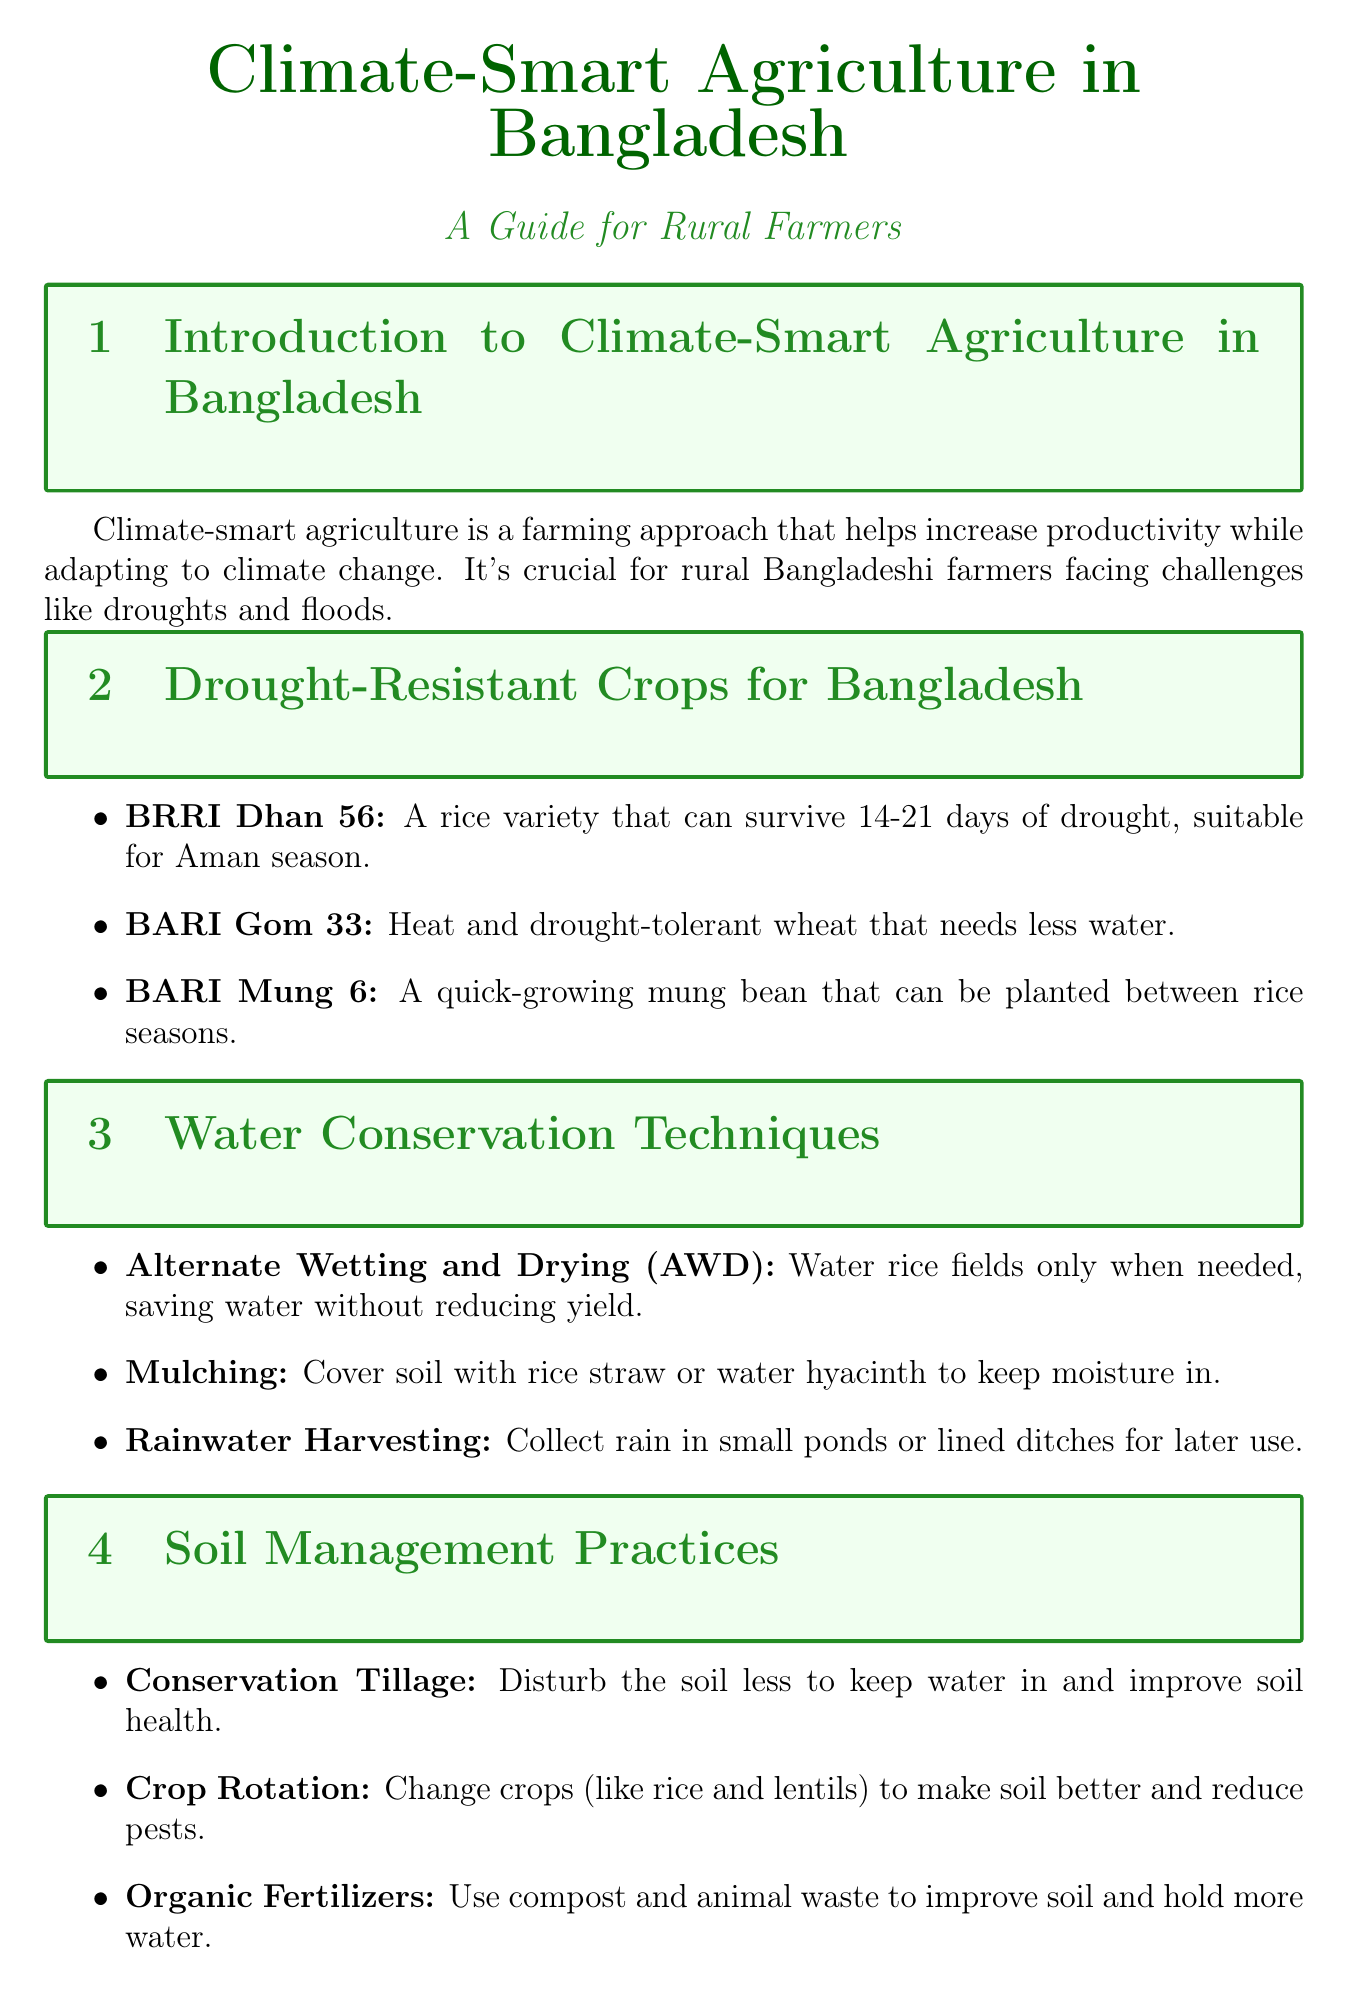What is climate-smart agriculture? The document defines climate-smart agriculture as a farming approach to increase productivity while adapting to climate change.
Answer: A farming approach What is the main benefit of BRRI Dhan 56? BRRI Dhan 56 is described as a rice variety that can survive 14-21 days of drought.
Answer: Survive 14-21 days of drought What irrigation technique uses water only when necessary? The document mentions Alternate Wetting and Drying (AWD) as an irrigation method that saves water without reducing yield.
Answer: Alternate Wetting and Drying (AWD) Which crop rotation helps improve soil? Crop rotation is mentioned as altering crops to improve soil fertility and reduce pests, with rice and legumes like lentils or mung beans as examples.
Answer: Rice and legumes How did Abdul Karim improve his yield? Abdul Karim adopted drought-resistant BRRI Dhan 56 and AWD irrigation, resulting in a 20% yield increase.
Answer: 20% yield increase What organization provides training programs for farmers? The Department of Agricultural Extension (DAE) is mentioned as offering training programs to support farmers.
Answer: Department of Agricultural Extension (DAE) How does rainwater harvesting benefit farmers? The document describes rainwater harvesting as a method for collecting and storing rain for irrigation, which helps sustain crops during dry seasons.
Answer: Collecting and storing rain What type of farmers does BRAC support? The report states that BRAC helps with climate-smart agriculture projects in northern Bangladesh.
Answer: Northern Bangladesh farmers What is the importance of knowledge sharing among farmers? The report emphasizes that sharing knowledge can help scale up successful practices across rural Bangladesh.
Answer: Scale up successful practices 